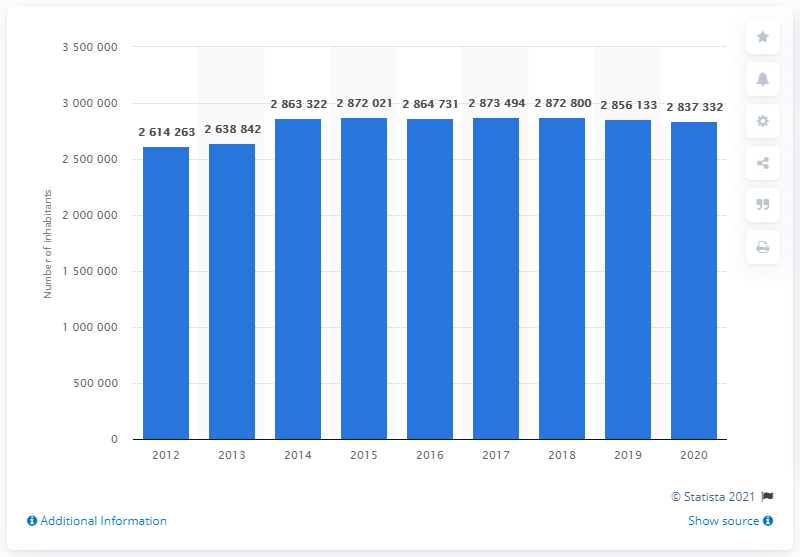Could you tell me the significance of the source mentioned in the image? The source indicated in the image, Statista 2021, suggests that this data was compiled and verified by Statista, a reputable company specializing in market and consumer data. It adds credibility to the information presented in the graph. How might this population data be useful? Population data such as this can be vital for urban planning, resource allocation, and assessing the need for services and infrastructure. It can also provide insights into demographic trends and help forecast future population changes. 